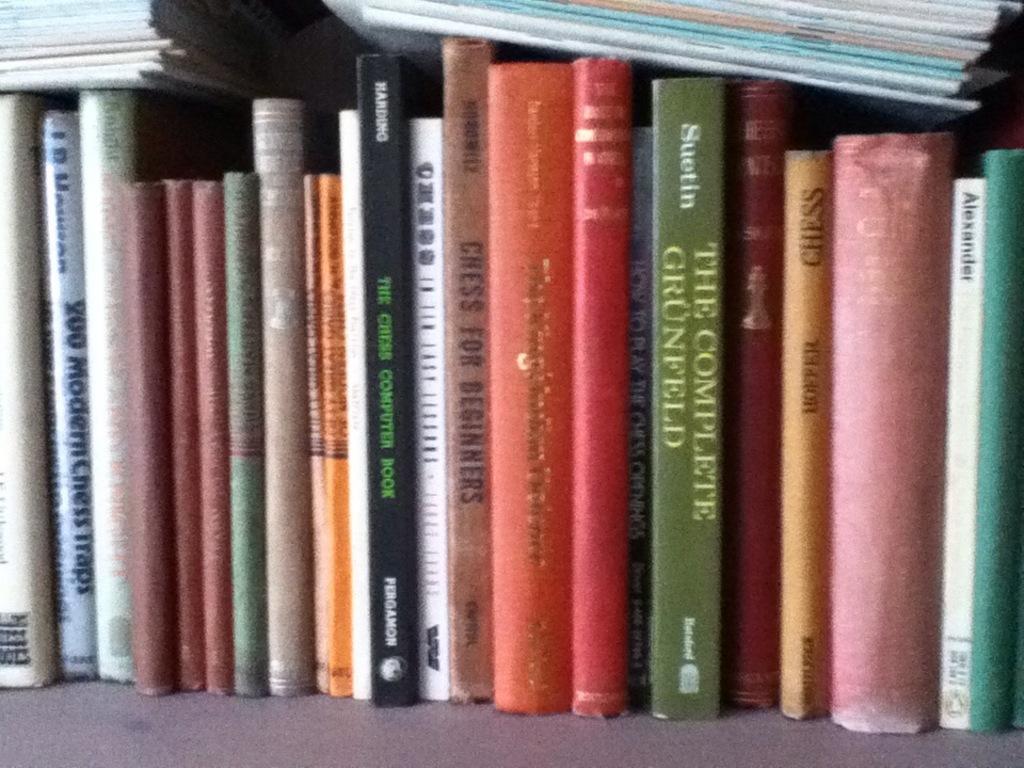What is the book in green called?
Your answer should be compact. The complete grunfeld. 